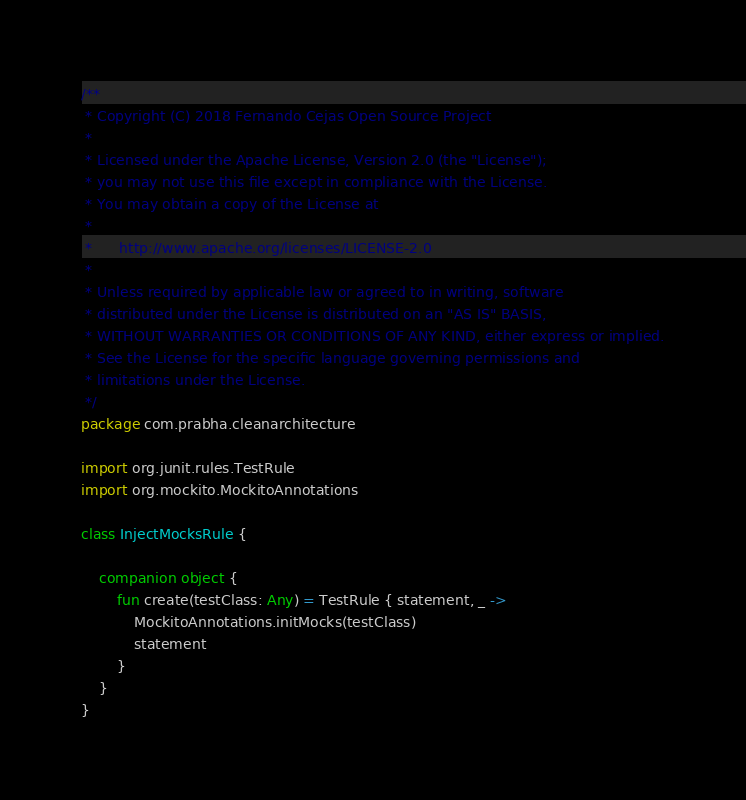Convert code to text. <code><loc_0><loc_0><loc_500><loc_500><_Kotlin_>/**
 * Copyright (C) 2018 Fernando Cejas Open Source Project
 *
 * Licensed under the Apache License, Version 2.0 (the "License");
 * you may not use this file except in compliance with the License.
 * You may obtain a copy of the License at
 *
 *      http://www.apache.org/licenses/LICENSE-2.0
 *
 * Unless required by applicable law or agreed to in writing, software
 * distributed under the License is distributed on an "AS IS" BASIS,
 * WITHOUT WARRANTIES OR CONDITIONS OF ANY KIND, either express or implied.
 * See the License for the specific language governing permissions and
 * limitations under the License.
 */
package com.prabha.cleanarchitecture

import org.junit.rules.TestRule
import org.mockito.MockitoAnnotations

class InjectMocksRule {

    companion object {
        fun create(testClass: Any) = TestRule { statement, _ ->
            MockitoAnnotations.initMocks(testClass)
            statement
        }
    }
}
</code> 